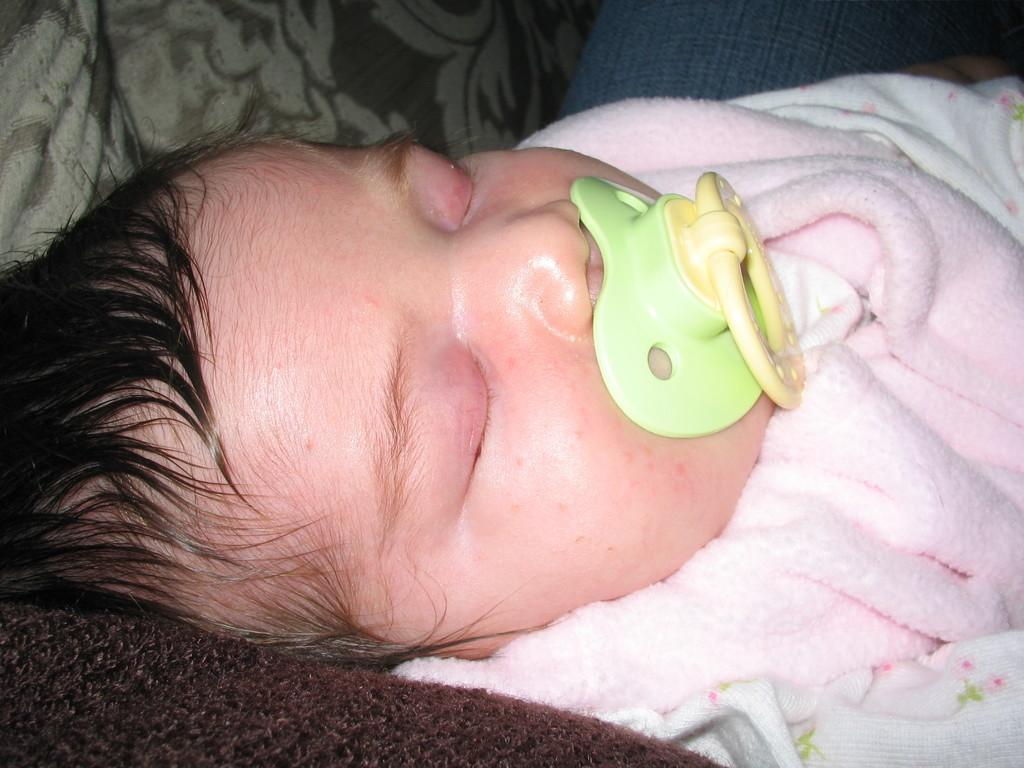What is the main subject of the image? The main subject of the image is an infant. What is the infant doing in the image? The infant is sleeping in the image. What is in the infant's mouth? The infant has a pacifier in their mouth. What color is the cloth that the infant is wrapped in? The infant is wrapped in a pink cloth. What type of copper lock can be seen securing the infant's crib in the image? There is no copper lock or crib present in the image; it features an infant wrapped in a pink cloth and sleeping. 